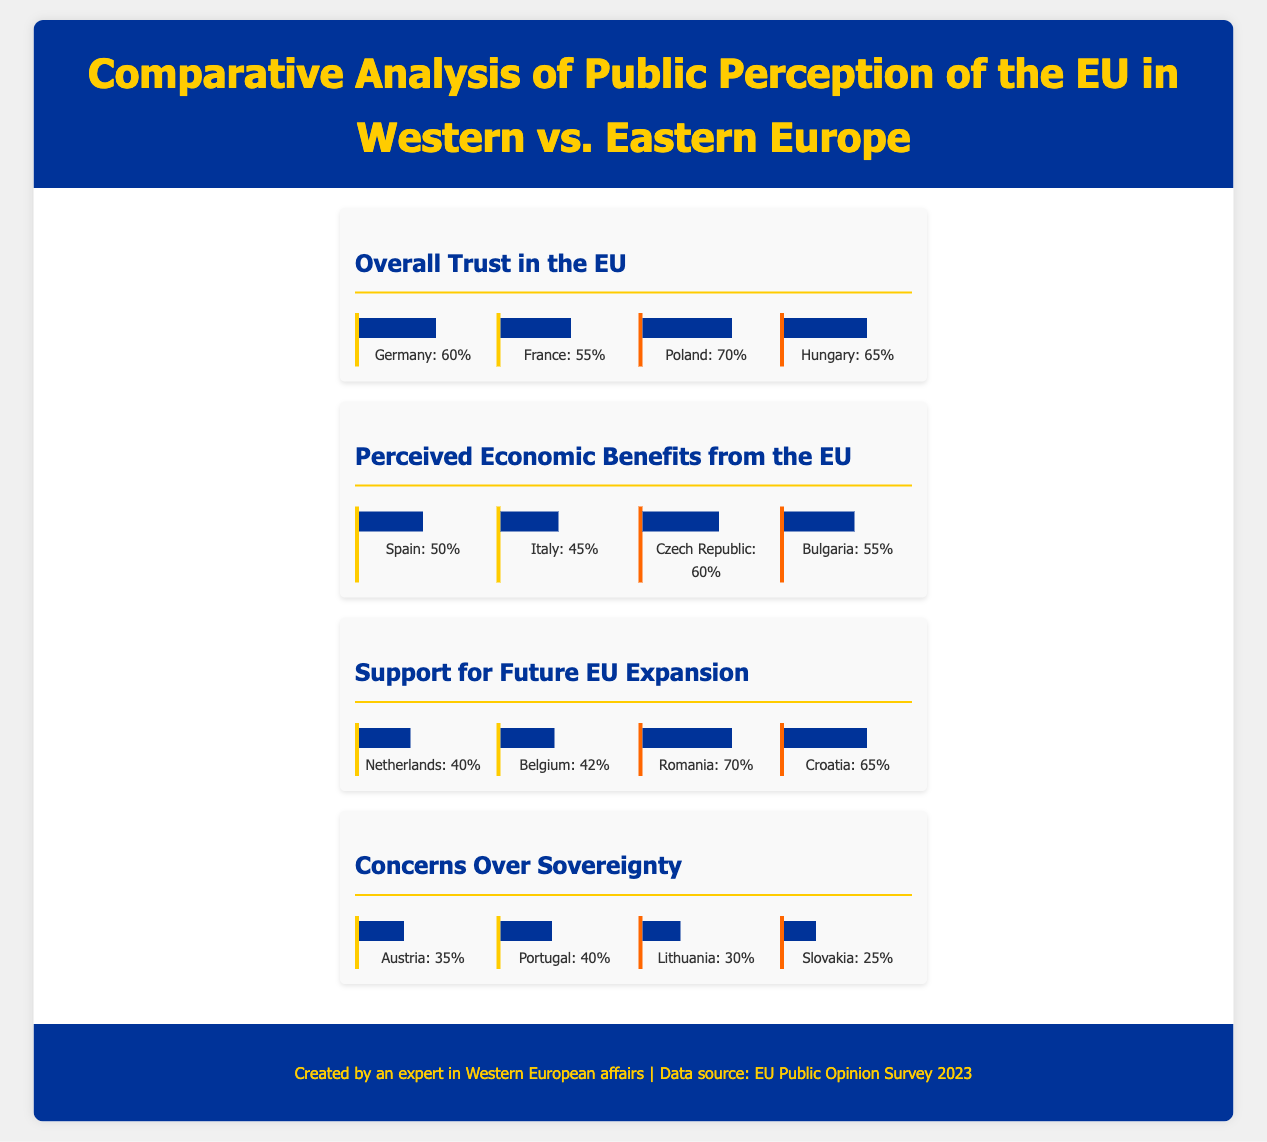what percentage of trust in the EU is reported in Germany? The document states that Germany has a trust level of 60% in the EU.
Answer: 60% which eastern European country has the highest perceived economic benefits from the EU? The heat map shows that the Czech Republic has a perceived economic benefit level of 60%, which is the highest in the east.
Answer: Czech Republic what is the support percentage for future EU expansion in Romania? The document indicates that Romania supports EU expansion at a rate of 70%.
Answer: 70% how does the perceived support for future EU expansion in the Netherlands compare to Romania? The Netherlands shows 40% support, which is significantly lower than Romania's 70%.
Answer: Lower what is the percentage of concerns over sovereignty in Slovakia? The document states that concerns over sovereignty in Slovakia are at 25%.
Answer: 25% which western European country expresses the least concern over sovereignty? According to the heat map, Austria shows the least concern with 35%.
Answer: Austria what are the percentages of perceived economic benefits from the EU in Spain and Italy? Spain has 50% and Italy has 45% in perceived economic benefits from the EU.
Answer: Spain: 50%, Italy: 45% how does trust in the EU in Hungary compare with France? Hungary has a trust level of 65%, which is higher than France's 55%.
Answer: Higher what overall trend can be observed regarding support for EU expansion between western and eastern Europe? Eastern Europe shows significantly higher support for EU expansion than western Europe.
Answer: Higher in Eastern Europe 